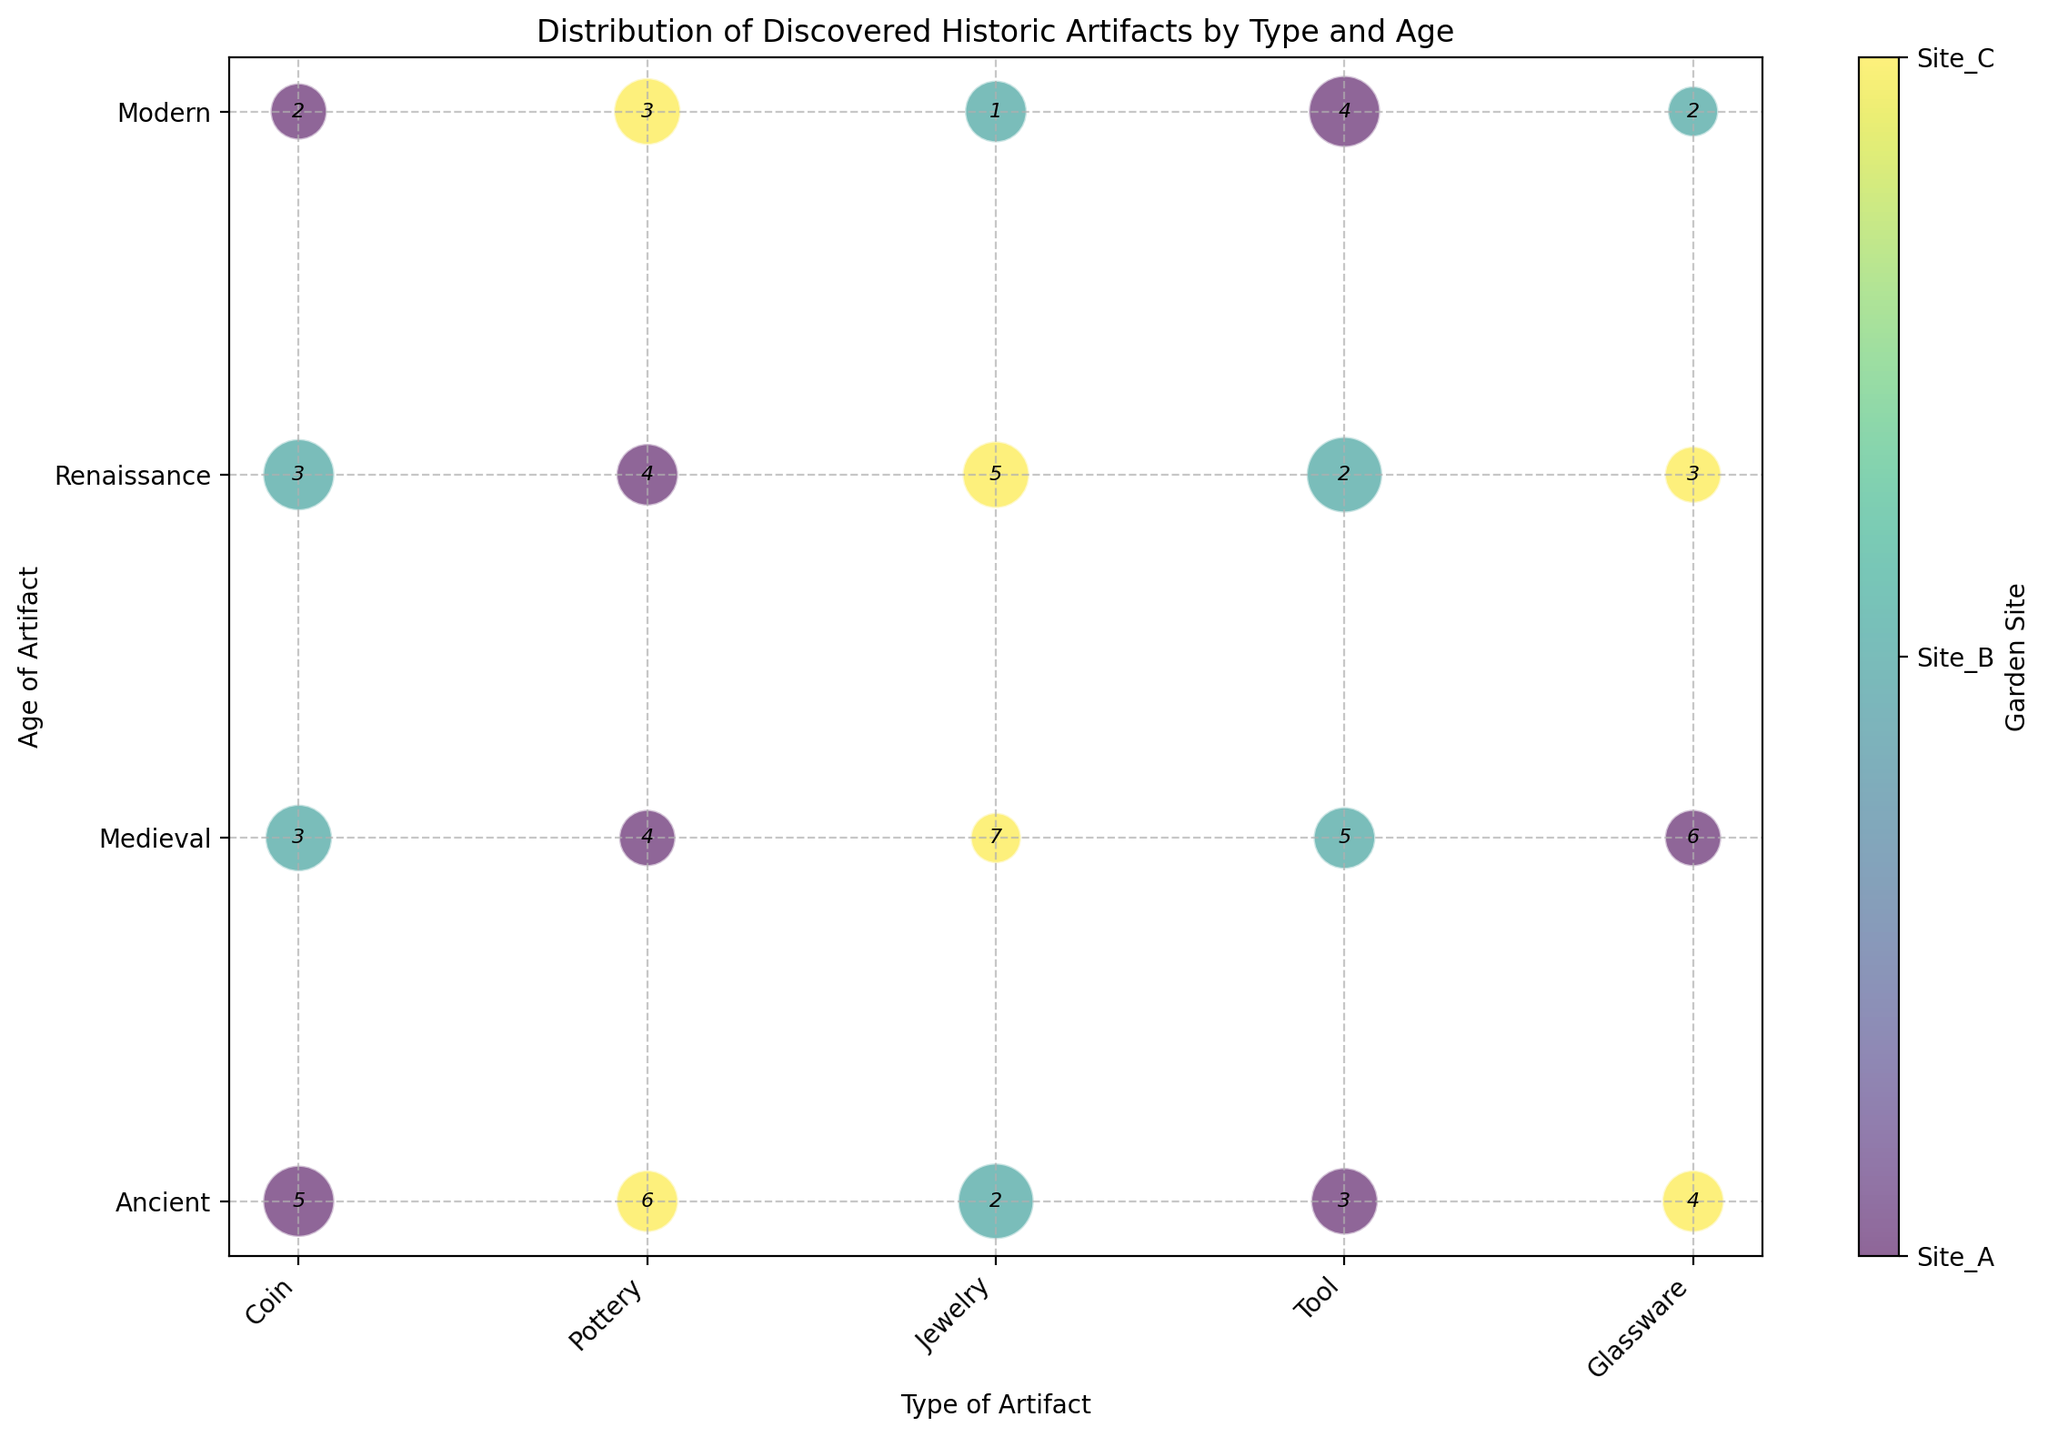Which type of artifact from the Renaissance age at Site_C has the largest bubble? Observe the bubbles categorized by age "Renaissance" on the y-axis. Among them, find those associated with Site_C by the specific color assigned to Site_C. Compare the sizes, and identify which type has the largest bubble (Pottery, Coin, Jewelry, Tool, Glassware).
Answer: Jewelry Which two garden sites have artifacts classified as Medieval Coins, and how does the frequency of discoveries compare between them? Locate the "Coin" artifact on the x-axis and then find the bubbles corresponding to the "Medieval" age on the y-axis. Identify the garden sites by their colors. Compare the frequency numbers annotated on these bubbles.
Answer: Site_B: 3, Site_A: 5 What artifact type from the Ancient age is most important at Site_B? Locate the “Ancient” age on the y-axis, then find the bubbles corresponding to Site_B by its color. Compare the sizes of the bubbles to determine which is the largest (Coin, Jewelry, Tool, Glassware).
Answer: Jewelry Between Site_A and Site_C, which has more Modern-age Pottery discoveries, and what are their frequencies? Locate the “Pottery” artifact type on the x-axis and then identify “Modern” age bubbles on the y-axis. Compare the frequencies annotated on the bubbles between Site_A and Site_C.
Answer: Site_A: 3, Site_C: 4 Which type of artifact at Site_A has the highest frequency in the Ancient age and what is its importance value? Locate the “Ancient” age on the y-axis, find the bubbles for Site_A by its color. Identify the largest bubble, then note the associated frequency and importance values (Coin, Pottery, Tool).
Answer: Coin, Frequency: 5, Importance: 8 Compare the importance of the Renaissance Jewelry discovered between Site_B and Site_C, which site has a higher value? Locate the “Jewelry” artifact type on the x-axis and find the bubbles corresponding to the “Renaissance” age on the y-axis. Compare the size of bubbles for Site_B and Site_C to determine which one is larger.
Answer: Site_C How does the frequency of Renaissance Coin discoveries at Site_B compare to Tools found at Site_B the same age? Locate the “Renaissance” age on the y-axis and compare the bubbles for “Coin” and “Tool” artifact types at Site_B indicated by their color. Read and compare the frequencies annotated on these bubbles.
Answer: Coin: 3, Tool: 2 